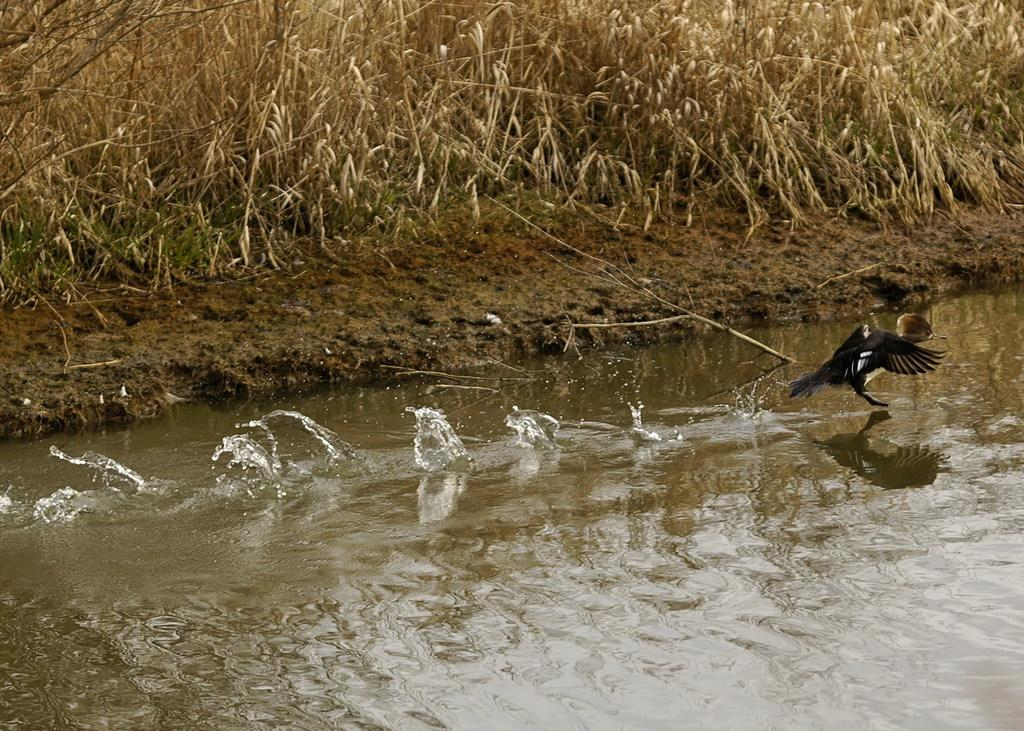What body of water is present in the image? There is a lake in the image. What type of animal can be seen on the lake? There is a bird on the lake. What type of vegetation is visible in the image? There is dried grass visible in the image. What type of news is the grandfather reading in the image? There is no grandfather or news present in the image. 